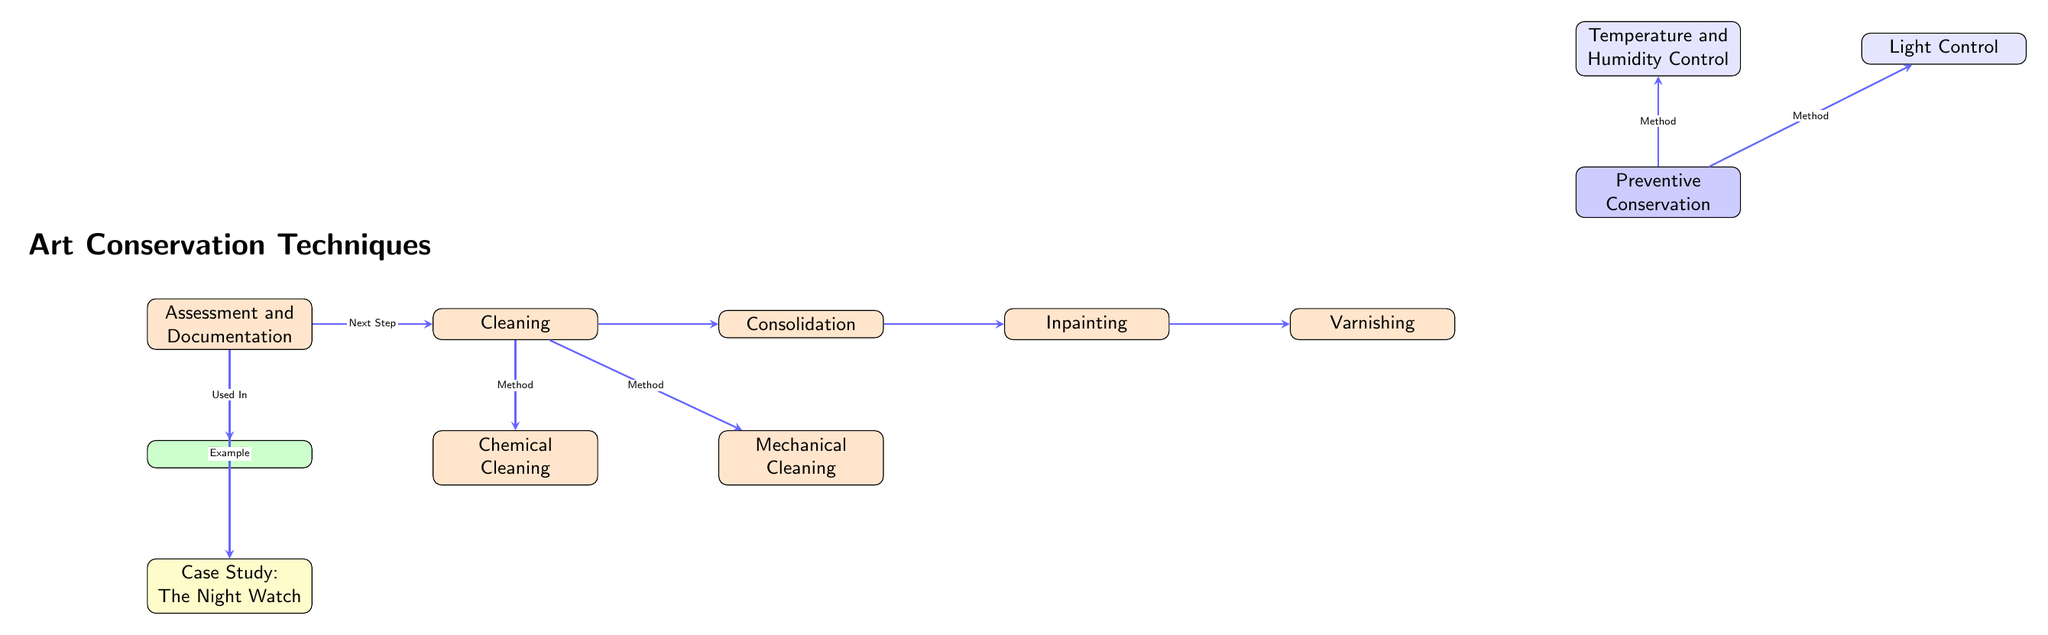What is the first step in art conservation techniques? The flowchart indicates that the first step is "Assessment and Documentation," which is the leftmost box in the main process sequence.
Answer: Assessment and Documentation How many main steps are listed in the art conservation flowchart? There are five main steps listed: Assessment and Documentation, Cleaning, Consolidation, Inpainting, and Varnishing. This is determined by counting the boxes in the main process section.
Answer: 5 Which cleaning method is specifically labeled as a method in the diagram? The cleaning methods listed below the "Cleaning" step are "Chemical Cleaning" and "Mechanical Cleaning," both indicated with arrows leading from the "Cleaning" box.
Answer: Chemical Cleaning and Mechanical Cleaning What two environmental control methods are related to Preventive Conservation? The methods related to Preventive Conservation are "Temperature and Humidity Control" and "Light Control," which are both depicted above the "Varnishing" step, pointing to the left and right respectively.
Answer: Temperature and Humidity Control, Light Control What is the case study mentioned in the diagram? The case study highlighted in the diagram is "The Night Watch," which is indicated as an example associated with the "Assessment and Documentation" process.
Answer: The Night Watch Which step comes directly after Cleaning? According to the flowchart, the step that follows "Cleaning" is "Consolidation," as indicated by the arrow connecting these two boxes.
Answer: Consolidation What color represents the Tools section in the diagram? The Tools section is filled with green color, as shown in the diagram by the color used in the box labeled "Tools."
Answer: Green What is the purpose of the arrows in the flowchart? The arrows in the flowchart serve to indicate the direction of the process flow, showing the progression from one step to the next in the art conservation techniques.
Answer: Indicate process flow 